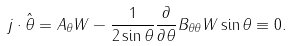<formula> <loc_0><loc_0><loc_500><loc_500>j \cdot \hat { \theta } = A _ { \theta } W - \frac { 1 } { 2 \sin \theta } \frac { \partial } { \partial \theta } B _ { \theta \theta } W \sin \theta \equiv 0 .</formula> 